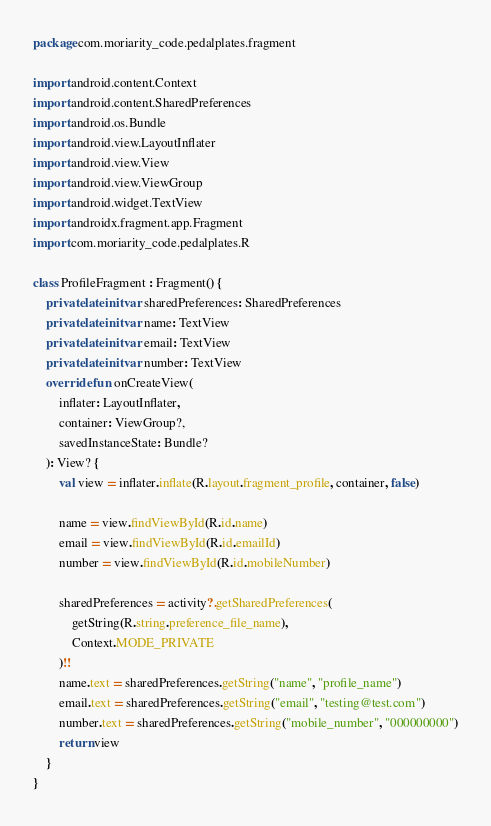Convert code to text. <code><loc_0><loc_0><loc_500><loc_500><_Kotlin_>package com.moriarity_code.pedalplates.fragment

import android.content.Context
import android.content.SharedPreferences
import android.os.Bundle
import android.view.LayoutInflater
import android.view.View
import android.view.ViewGroup
import android.widget.TextView
import androidx.fragment.app.Fragment
import com.moriarity_code.pedalplates.R

class ProfileFragment : Fragment() {
    private lateinit var sharedPreferences: SharedPreferences
    private lateinit var name: TextView
    private lateinit var email: TextView
    private lateinit var number: TextView
    override fun onCreateView(
        inflater: LayoutInflater,
        container: ViewGroup?,
        savedInstanceState: Bundle?
    ): View? {
        val view = inflater.inflate(R.layout.fragment_profile, container, false)

        name = view.findViewById(R.id.name)
        email = view.findViewById(R.id.emailId)
        number = view.findViewById(R.id.mobileNumber)

        sharedPreferences = activity?.getSharedPreferences(
            getString(R.string.preference_file_name),
            Context.MODE_PRIVATE
        )!!
        name.text = sharedPreferences.getString("name", "profile_name")
        email.text = sharedPreferences.getString("email", "testing@test.com")
        number.text = sharedPreferences.getString("mobile_number", "000000000")
        return view
    }
}</code> 